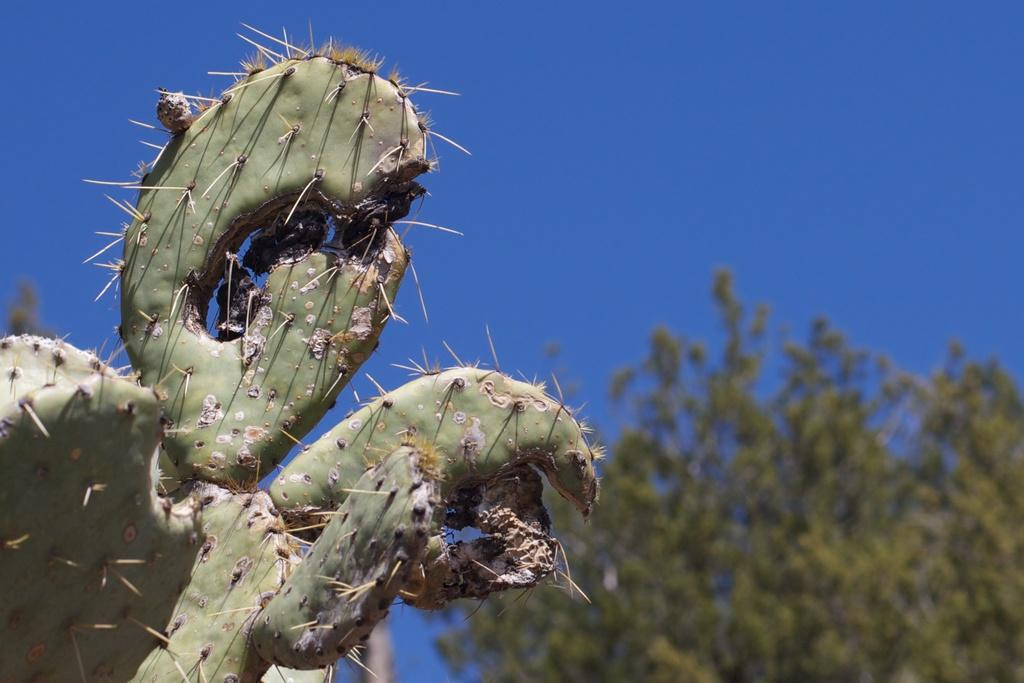What type of vegetation is present in the image? There is a plant and trees in the image. What can be seen in the background of the image? The sky is visible in the background of the image. How many pizzas are hanging from the branches of the trees in the image? There are no pizzas present in the image; it features a plant, trees, and the sky. 